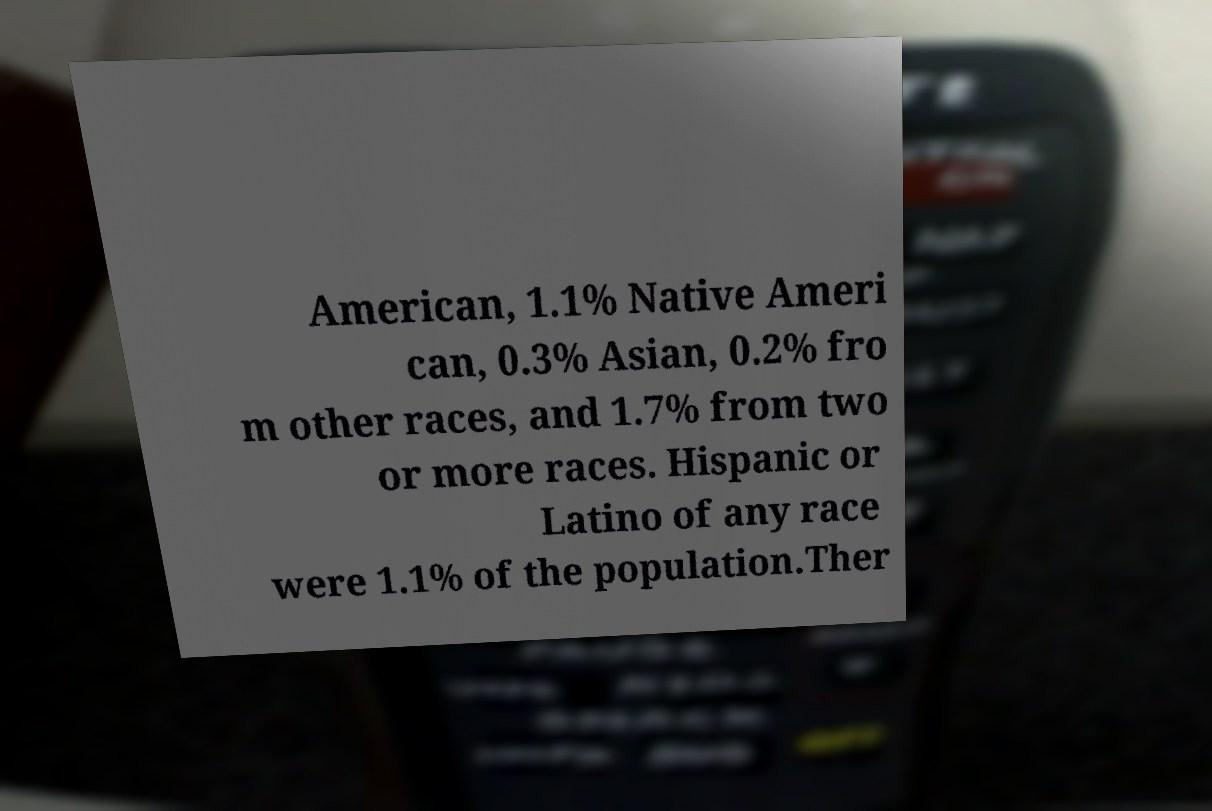For documentation purposes, I need the text within this image transcribed. Could you provide that? American, 1.1% Native Ameri can, 0.3% Asian, 0.2% fro m other races, and 1.7% from two or more races. Hispanic or Latino of any race were 1.1% of the population.Ther 